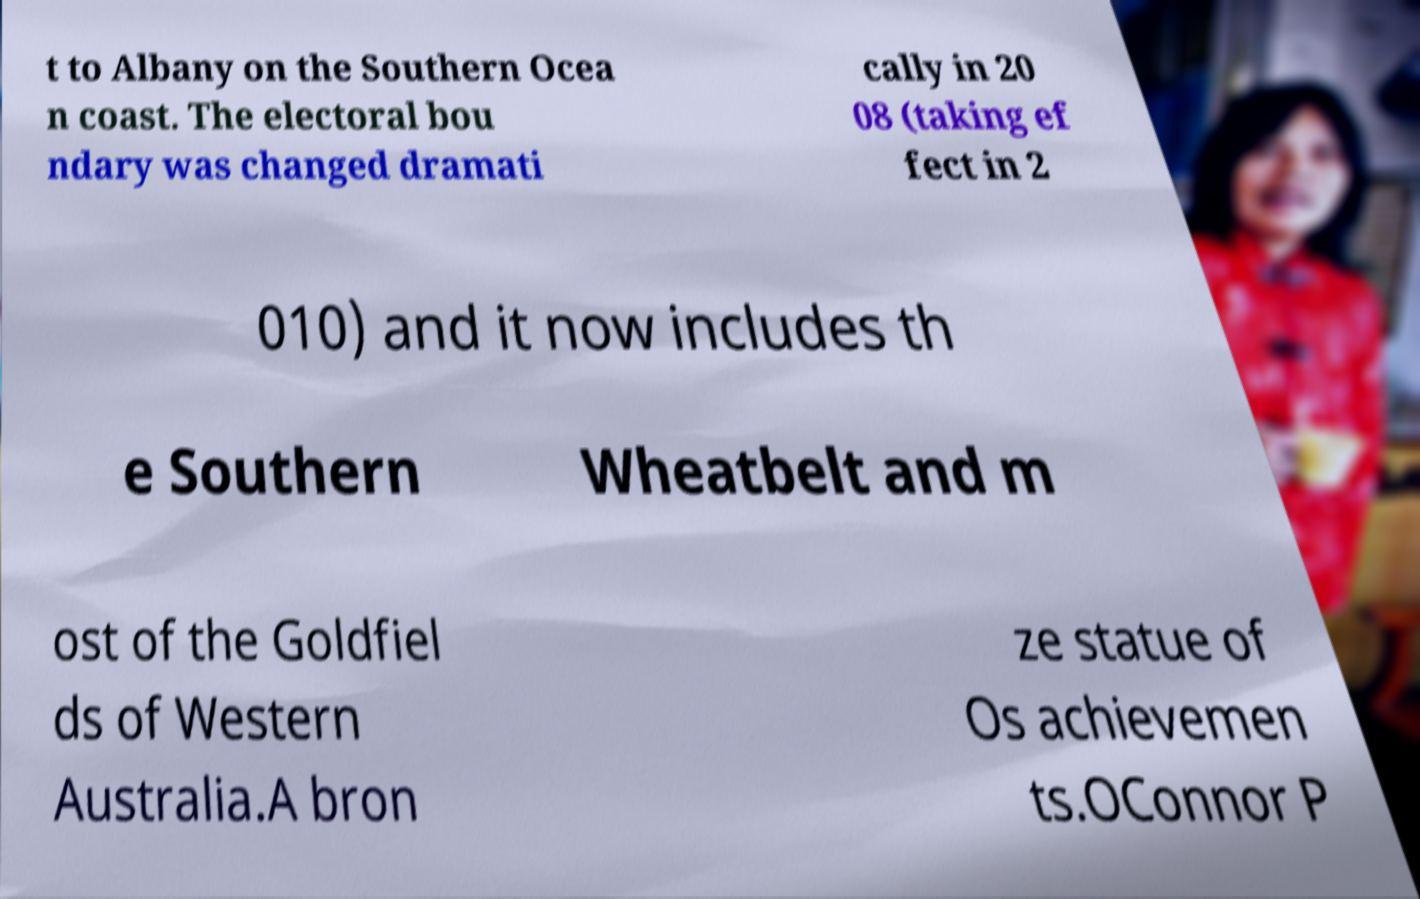Could you assist in decoding the text presented in this image and type it out clearly? t to Albany on the Southern Ocea n coast. The electoral bou ndary was changed dramati cally in 20 08 (taking ef fect in 2 010) and it now includes th e Southern Wheatbelt and m ost of the Goldfiel ds of Western Australia.A bron ze statue of Os achievemen ts.OConnor P 